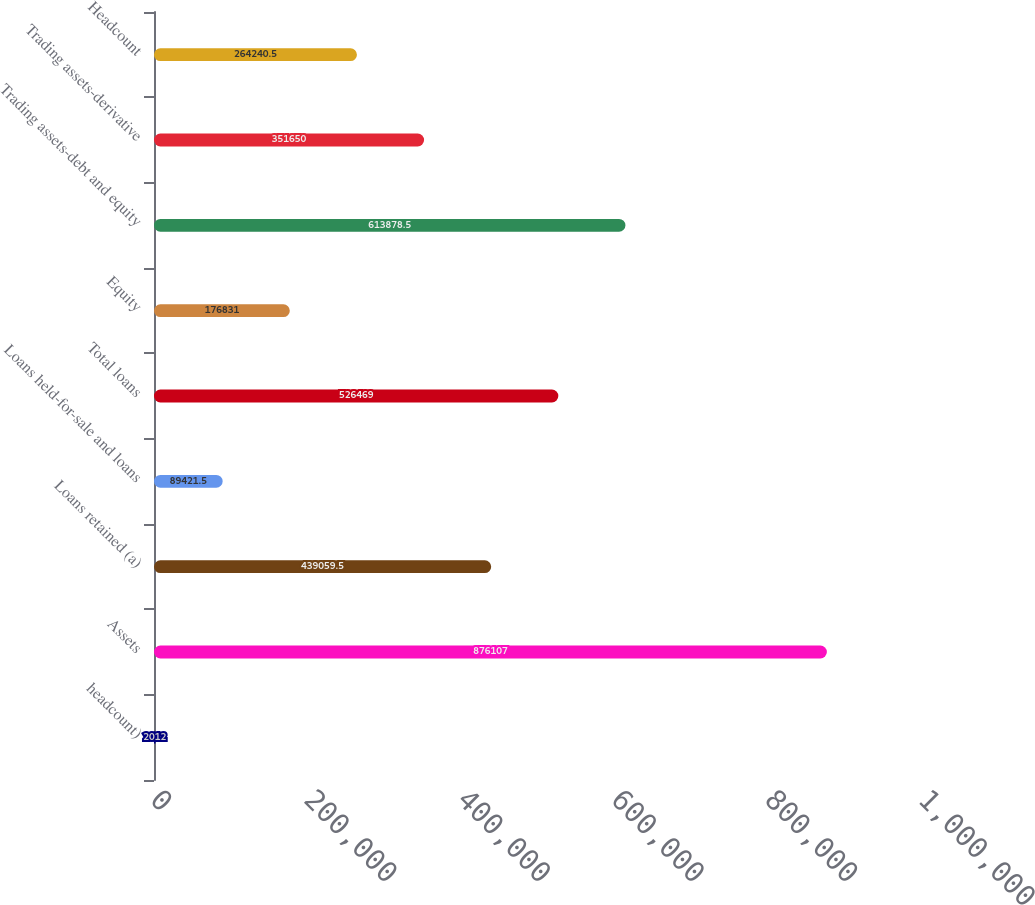Convert chart. <chart><loc_0><loc_0><loc_500><loc_500><bar_chart><fcel>headcount)<fcel>Assets<fcel>Loans retained (a)<fcel>Loans held-for-sale and loans<fcel>Total loans<fcel>Equity<fcel>Trading assets-debt and equity<fcel>Trading assets-derivative<fcel>Headcount<nl><fcel>2012<fcel>876107<fcel>439060<fcel>89421.5<fcel>526469<fcel>176831<fcel>613878<fcel>351650<fcel>264240<nl></chart> 